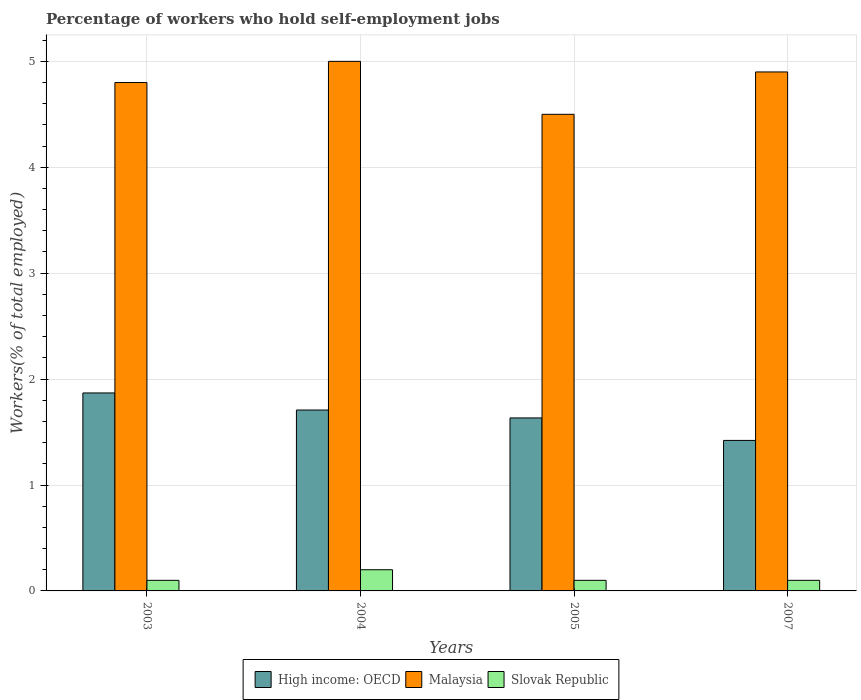How many different coloured bars are there?
Offer a very short reply. 3. How many groups of bars are there?
Offer a very short reply. 4. Are the number of bars per tick equal to the number of legend labels?
Make the answer very short. Yes. Are the number of bars on each tick of the X-axis equal?
Your answer should be compact. Yes. How many bars are there on the 1st tick from the left?
Give a very brief answer. 3. How many bars are there on the 1st tick from the right?
Ensure brevity in your answer.  3. In how many cases, is the number of bars for a given year not equal to the number of legend labels?
Your response must be concise. 0. Across all years, what is the maximum percentage of self-employed workers in High income: OECD?
Provide a short and direct response. 1.87. Across all years, what is the minimum percentage of self-employed workers in High income: OECD?
Give a very brief answer. 1.42. In which year was the percentage of self-employed workers in Malaysia maximum?
Give a very brief answer. 2004. In which year was the percentage of self-employed workers in Slovak Republic minimum?
Offer a terse response. 2003. What is the total percentage of self-employed workers in Malaysia in the graph?
Make the answer very short. 19.2. What is the difference between the percentage of self-employed workers in High income: OECD in 2003 and that in 2007?
Give a very brief answer. 0.45. What is the difference between the percentage of self-employed workers in High income: OECD in 2007 and the percentage of self-employed workers in Slovak Republic in 2005?
Ensure brevity in your answer.  1.32. What is the average percentage of self-employed workers in High income: OECD per year?
Provide a short and direct response. 1.66. In the year 2005, what is the difference between the percentage of self-employed workers in High income: OECD and percentage of self-employed workers in Slovak Republic?
Your response must be concise. 1.53. In how many years, is the percentage of self-employed workers in High income: OECD greater than 2.4 %?
Provide a short and direct response. 0. What is the ratio of the percentage of self-employed workers in Malaysia in 2004 to that in 2007?
Provide a succinct answer. 1.02. What is the difference between the highest and the second highest percentage of self-employed workers in Malaysia?
Make the answer very short. 0.1. What is the difference between the highest and the lowest percentage of self-employed workers in Malaysia?
Give a very brief answer. 0.5. What does the 3rd bar from the left in 2005 represents?
Give a very brief answer. Slovak Republic. What does the 1st bar from the right in 2005 represents?
Keep it short and to the point. Slovak Republic. Are all the bars in the graph horizontal?
Your answer should be compact. No. Does the graph contain grids?
Make the answer very short. Yes. How many legend labels are there?
Your response must be concise. 3. How are the legend labels stacked?
Your response must be concise. Horizontal. What is the title of the graph?
Your answer should be compact. Percentage of workers who hold self-employment jobs. What is the label or title of the Y-axis?
Make the answer very short. Workers(% of total employed). What is the Workers(% of total employed) in High income: OECD in 2003?
Keep it short and to the point. 1.87. What is the Workers(% of total employed) in Malaysia in 2003?
Your answer should be compact. 4.8. What is the Workers(% of total employed) in Slovak Republic in 2003?
Your answer should be compact. 0.1. What is the Workers(% of total employed) of High income: OECD in 2004?
Offer a very short reply. 1.71. What is the Workers(% of total employed) in Malaysia in 2004?
Offer a terse response. 5. What is the Workers(% of total employed) of Slovak Republic in 2004?
Offer a very short reply. 0.2. What is the Workers(% of total employed) in High income: OECD in 2005?
Give a very brief answer. 1.63. What is the Workers(% of total employed) of Slovak Republic in 2005?
Give a very brief answer. 0.1. What is the Workers(% of total employed) in High income: OECD in 2007?
Provide a succinct answer. 1.42. What is the Workers(% of total employed) of Malaysia in 2007?
Make the answer very short. 4.9. What is the Workers(% of total employed) of Slovak Republic in 2007?
Ensure brevity in your answer.  0.1. Across all years, what is the maximum Workers(% of total employed) in High income: OECD?
Offer a terse response. 1.87. Across all years, what is the maximum Workers(% of total employed) in Slovak Republic?
Ensure brevity in your answer.  0.2. Across all years, what is the minimum Workers(% of total employed) in High income: OECD?
Ensure brevity in your answer.  1.42. Across all years, what is the minimum Workers(% of total employed) in Slovak Republic?
Make the answer very short. 0.1. What is the total Workers(% of total employed) of High income: OECD in the graph?
Ensure brevity in your answer.  6.63. What is the total Workers(% of total employed) of Slovak Republic in the graph?
Ensure brevity in your answer.  0.5. What is the difference between the Workers(% of total employed) of High income: OECD in 2003 and that in 2004?
Give a very brief answer. 0.16. What is the difference between the Workers(% of total employed) in Malaysia in 2003 and that in 2004?
Provide a succinct answer. -0.2. What is the difference between the Workers(% of total employed) of Slovak Republic in 2003 and that in 2004?
Provide a short and direct response. -0.1. What is the difference between the Workers(% of total employed) in High income: OECD in 2003 and that in 2005?
Offer a very short reply. 0.24. What is the difference between the Workers(% of total employed) of Malaysia in 2003 and that in 2005?
Your answer should be compact. 0.3. What is the difference between the Workers(% of total employed) of Slovak Republic in 2003 and that in 2005?
Your answer should be very brief. 0. What is the difference between the Workers(% of total employed) of High income: OECD in 2003 and that in 2007?
Offer a terse response. 0.45. What is the difference between the Workers(% of total employed) in High income: OECD in 2004 and that in 2005?
Ensure brevity in your answer.  0.07. What is the difference between the Workers(% of total employed) of Malaysia in 2004 and that in 2005?
Make the answer very short. 0.5. What is the difference between the Workers(% of total employed) in Slovak Republic in 2004 and that in 2005?
Ensure brevity in your answer.  0.1. What is the difference between the Workers(% of total employed) of High income: OECD in 2004 and that in 2007?
Your answer should be very brief. 0.29. What is the difference between the Workers(% of total employed) in High income: OECD in 2005 and that in 2007?
Offer a very short reply. 0.21. What is the difference between the Workers(% of total employed) of Malaysia in 2005 and that in 2007?
Offer a terse response. -0.4. What is the difference between the Workers(% of total employed) of Slovak Republic in 2005 and that in 2007?
Provide a succinct answer. 0. What is the difference between the Workers(% of total employed) of High income: OECD in 2003 and the Workers(% of total employed) of Malaysia in 2004?
Provide a short and direct response. -3.13. What is the difference between the Workers(% of total employed) of High income: OECD in 2003 and the Workers(% of total employed) of Slovak Republic in 2004?
Give a very brief answer. 1.67. What is the difference between the Workers(% of total employed) in High income: OECD in 2003 and the Workers(% of total employed) in Malaysia in 2005?
Offer a terse response. -2.63. What is the difference between the Workers(% of total employed) of High income: OECD in 2003 and the Workers(% of total employed) of Slovak Republic in 2005?
Keep it short and to the point. 1.77. What is the difference between the Workers(% of total employed) of High income: OECD in 2003 and the Workers(% of total employed) of Malaysia in 2007?
Your answer should be very brief. -3.03. What is the difference between the Workers(% of total employed) in High income: OECD in 2003 and the Workers(% of total employed) in Slovak Republic in 2007?
Provide a short and direct response. 1.77. What is the difference between the Workers(% of total employed) in Malaysia in 2003 and the Workers(% of total employed) in Slovak Republic in 2007?
Your answer should be very brief. 4.7. What is the difference between the Workers(% of total employed) of High income: OECD in 2004 and the Workers(% of total employed) of Malaysia in 2005?
Give a very brief answer. -2.79. What is the difference between the Workers(% of total employed) in High income: OECD in 2004 and the Workers(% of total employed) in Slovak Republic in 2005?
Your response must be concise. 1.61. What is the difference between the Workers(% of total employed) in Malaysia in 2004 and the Workers(% of total employed) in Slovak Republic in 2005?
Your answer should be compact. 4.9. What is the difference between the Workers(% of total employed) of High income: OECD in 2004 and the Workers(% of total employed) of Malaysia in 2007?
Give a very brief answer. -3.19. What is the difference between the Workers(% of total employed) in High income: OECD in 2004 and the Workers(% of total employed) in Slovak Republic in 2007?
Make the answer very short. 1.61. What is the difference between the Workers(% of total employed) in Malaysia in 2004 and the Workers(% of total employed) in Slovak Republic in 2007?
Make the answer very short. 4.9. What is the difference between the Workers(% of total employed) in High income: OECD in 2005 and the Workers(% of total employed) in Malaysia in 2007?
Your answer should be compact. -3.27. What is the difference between the Workers(% of total employed) in High income: OECD in 2005 and the Workers(% of total employed) in Slovak Republic in 2007?
Your answer should be very brief. 1.53. What is the average Workers(% of total employed) in High income: OECD per year?
Make the answer very short. 1.66. What is the average Workers(% of total employed) of Malaysia per year?
Offer a terse response. 4.8. What is the average Workers(% of total employed) of Slovak Republic per year?
Ensure brevity in your answer.  0.12. In the year 2003, what is the difference between the Workers(% of total employed) of High income: OECD and Workers(% of total employed) of Malaysia?
Provide a succinct answer. -2.93. In the year 2003, what is the difference between the Workers(% of total employed) in High income: OECD and Workers(% of total employed) in Slovak Republic?
Keep it short and to the point. 1.77. In the year 2004, what is the difference between the Workers(% of total employed) in High income: OECD and Workers(% of total employed) in Malaysia?
Ensure brevity in your answer.  -3.29. In the year 2004, what is the difference between the Workers(% of total employed) of High income: OECD and Workers(% of total employed) of Slovak Republic?
Provide a succinct answer. 1.51. In the year 2005, what is the difference between the Workers(% of total employed) of High income: OECD and Workers(% of total employed) of Malaysia?
Offer a terse response. -2.87. In the year 2005, what is the difference between the Workers(% of total employed) in High income: OECD and Workers(% of total employed) in Slovak Republic?
Ensure brevity in your answer.  1.53. In the year 2005, what is the difference between the Workers(% of total employed) of Malaysia and Workers(% of total employed) of Slovak Republic?
Make the answer very short. 4.4. In the year 2007, what is the difference between the Workers(% of total employed) in High income: OECD and Workers(% of total employed) in Malaysia?
Offer a terse response. -3.48. In the year 2007, what is the difference between the Workers(% of total employed) of High income: OECD and Workers(% of total employed) of Slovak Republic?
Your answer should be compact. 1.32. In the year 2007, what is the difference between the Workers(% of total employed) of Malaysia and Workers(% of total employed) of Slovak Republic?
Make the answer very short. 4.8. What is the ratio of the Workers(% of total employed) of High income: OECD in 2003 to that in 2004?
Provide a succinct answer. 1.09. What is the ratio of the Workers(% of total employed) in Slovak Republic in 2003 to that in 2004?
Your response must be concise. 0.5. What is the ratio of the Workers(% of total employed) of High income: OECD in 2003 to that in 2005?
Keep it short and to the point. 1.14. What is the ratio of the Workers(% of total employed) in Malaysia in 2003 to that in 2005?
Your response must be concise. 1.07. What is the ratio of the Workers(% of total employed) in High income: OECD in 2003 to that in 2007?
Offer a very short reply. 1.32. What is the ratio of the Workers(% of total employed) in Malaysia in 2003 to that in 2007?
Make the answer very short. 0.98. What is the ratio of the Workers(% of total employed) of Slovak Republic in 2003 to that in 2007?
Offer a very short reply. 1. What is the ratio of the Workers(% of total employed) in High income: OECD in 2004 to that in 2005?
Your answer should be very brief. 1.05. What is the ratio of the Workers(% of total employed) of Slovak Republic in 2004 to that in 2005?
Provide a short and direct response. 2. What is the ratio of the Workers(% of total employed) of High income: OECD in 2004 to that in 2007?
Give a very brief answer. 1.2. What is the ratio of the Workers(% of total employed) of Malaysia in 2004 to that in 2007?
Your answer should be compact. 1.02. What is the ratio of the Workers(% of total employed) in High income: OECD in 2005 to that in 2007?
Keep it short and to the point. 1.15. What is the ratio of the Workers(% of total employed) in Malaysia in 2005 to that in 2007?
Provide a succinct answer. 0.92. What is the difference between the highest and the second highest Workers(% of total employed) of High income: OECD?
Give a very brief answer. 0.16. What is the difference between the highest and the second highest Workers(% of total employed) in Malaysia?
Your answer should be compact. 0.1. What is the difference between the highest and the second highest Workers(% of total employed) in Slovak Republic?
Keep it short and to the point. 0.1. What is the difference between the highest and the lowest Workers(% of total employed) of High income: OECD?
Provide a short and direct response. 0.45. What is the difference between the highest and the lowest Workers(% of total employed) of Slovak Republic?
Keep it short and to the point. 0.1. 